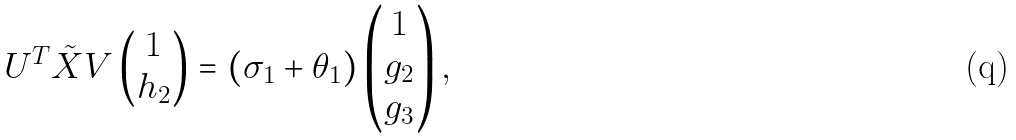<formula> <loc_0><loc_0><loc_500><loc_500>U ^ { T } \tilde { X } V \begin{pmatrix} 1 \\ h _ { 2 } \end{pmatrix} = ( \sigma _ { 1 } + \theta _ { 1 } ) \begin{pmatrix} 1 \\ g _ { 2 } \\ g _ { 3 } \end{pmatrix} ,</formula> 